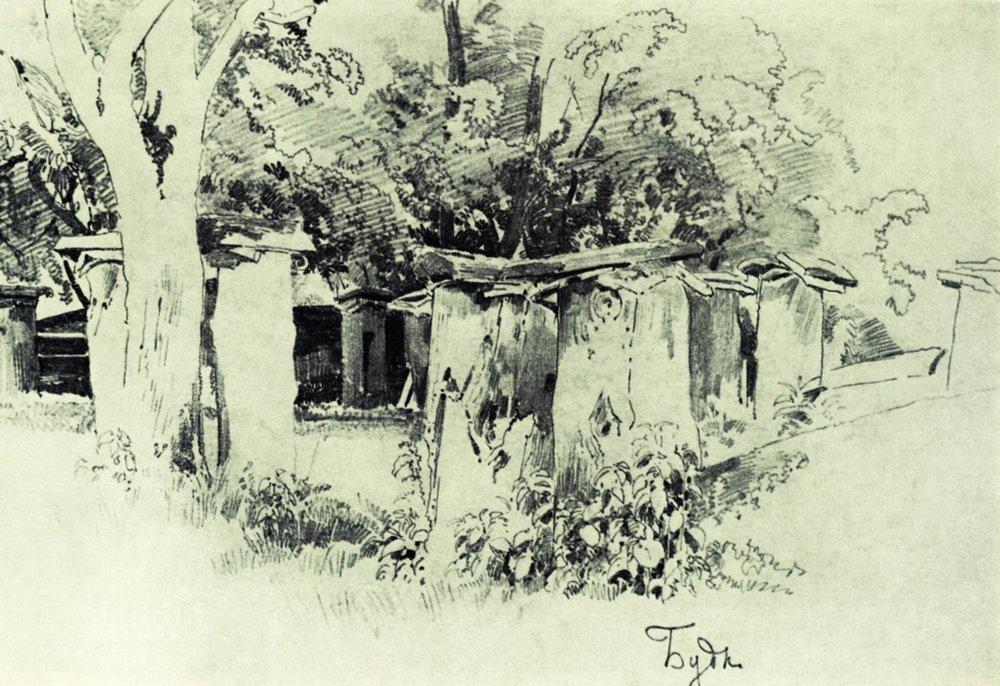What emotions does this scene evoke? The scene evokes a sense of calm and tranquility, capturing the essence of rural simplicity. The soft contrast between the dark silhouettes of the trees and the light background enhances the serene feeling, making the viewer feel relaxed and at peace. How might a day in this setting unfold? A day in this setting might begin with the gentle chirping of birds as dawn breaks over the peaceful countryside. The morning light filters through the trees, casting dappled shadows on the ground. Farmers may start their day early, tending to their gardens and fields. The village might slowly come to life with neighbors exchanging greetings and children playing around the houses. Afternoon may bring a quiet, relaxed atmosphere with the sun high in the sky and a cool breeze rustling through the leaves. As evening approaches, the sky turns into a canvas of warm hues, and families gather inside their cozy homes for dinner. The day ends with a tranquil night, the soft sound of crickets creating a soothing backdrop for restful sleep. Can you create a short story based on this image? Once upon a time, in a quaint village surrounded by tall, ancient trees, there lived a young artist named Arin. Arin loved spending his days under the canopy of leaves, capturing the serene beauty of his rural home with charcoal and paper. One quiet morning, as the first rays of sunlight streamed through the trees, Arin discovered a hidden path behind the bushes that led to an old, abandoned cottage. Curious and filled with wonder, he decided to explore it. Inside, he found remnants of old paintings, hinting at a story of a bygone era. Inspired by the mystery, Arin spent his days restoring the cottage and reviving the lost art, ultimately uncovering a rich history that connected his village to generations of artists before him. His work breathed new life into the village, and the hidden path became a symbol of endless discovery and creativity for dwellers and visitors alike. Imagine a magical creature that lives in this setting. Describe it in detail. In the tranquil village, nestled deep within the lush foliage, resides a gentle and magical creature known as the Whisperwood Sprite. This ethereal being is a guardian of nature, standing about three feet tall with a body composed of entwined vines and leaves that change colors with the seasons. In spring, the Whisperwood Sprite is adorned in vibrant greens and budding flowers; in summer, it glows with a golden hue, reflecting the sunlight; in autumn, it wears a cloak of russet and amber leaves; and in winter, its form turns into delicate, frosted branches. Its eyes shimmer like dew drops at dawn, and from its back sprout translucent wings that resemble stained glass windows, allowing it to glide gracefully through the air. The sprite communicates with the flora and fauna, ensuring the harmony of the ecosystem. It is said that those who catch a glimpse of the Whisperwood Sprite will be blessed with a deep sense of peace and an everlasting connection to nature. 